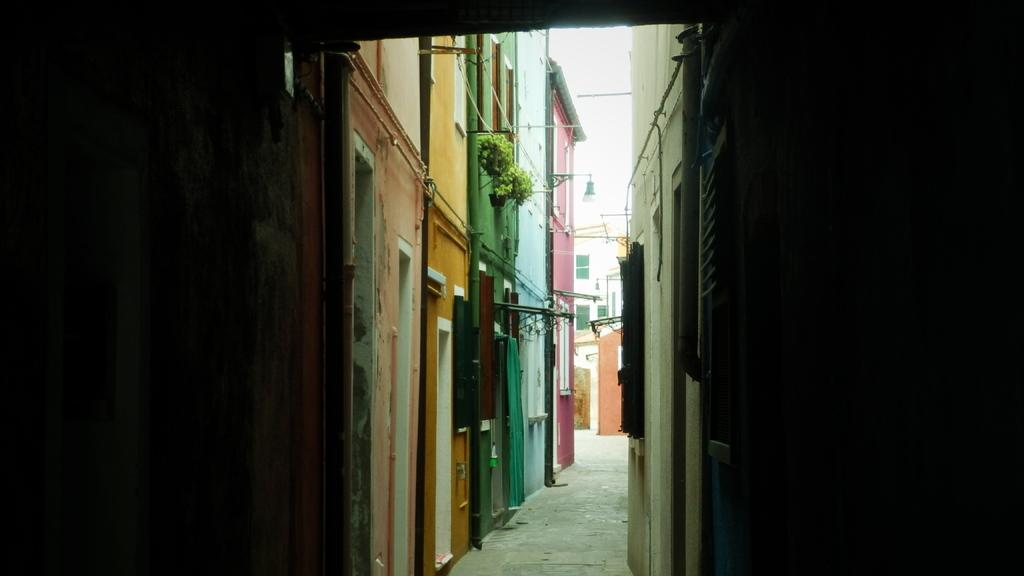What type of structures are present on both sides of the image? There are buildings on both sides of the image. What can be seen on the buildings? There are pipes and a pot with plants on the buildings. Can you describe the building in the background of the image? There is a building with windows in the background of the image. What type of cloud can be seen in the image? There is no cloud present in the image; it only features buildings with pipes and a pot with plants. What tool is being used to open the can in the image? There is no can or tool present in the image. 